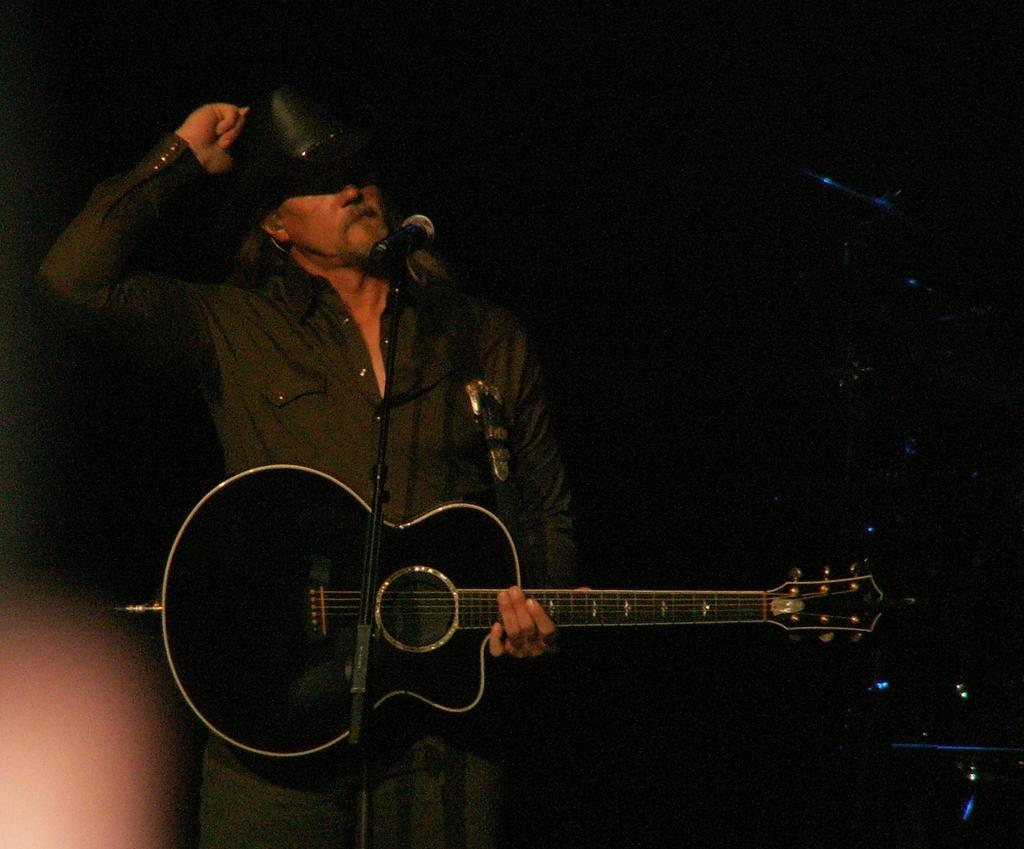What is the main subject of the image? The main subject of the image is a man. What is the man doing in the image? The man is standing in the image. What is the man wearing on his head? The man is wearing a cap on his head. What object is the man holding in the image? The man is holding a guitar in the image. What device is in front of the man? There is a microphone (mic) in front of the man. What type of yam is the man using to play the guitar in the image? There is no yam present in the image, and the man is using a guitar, not a yam, to make music. 